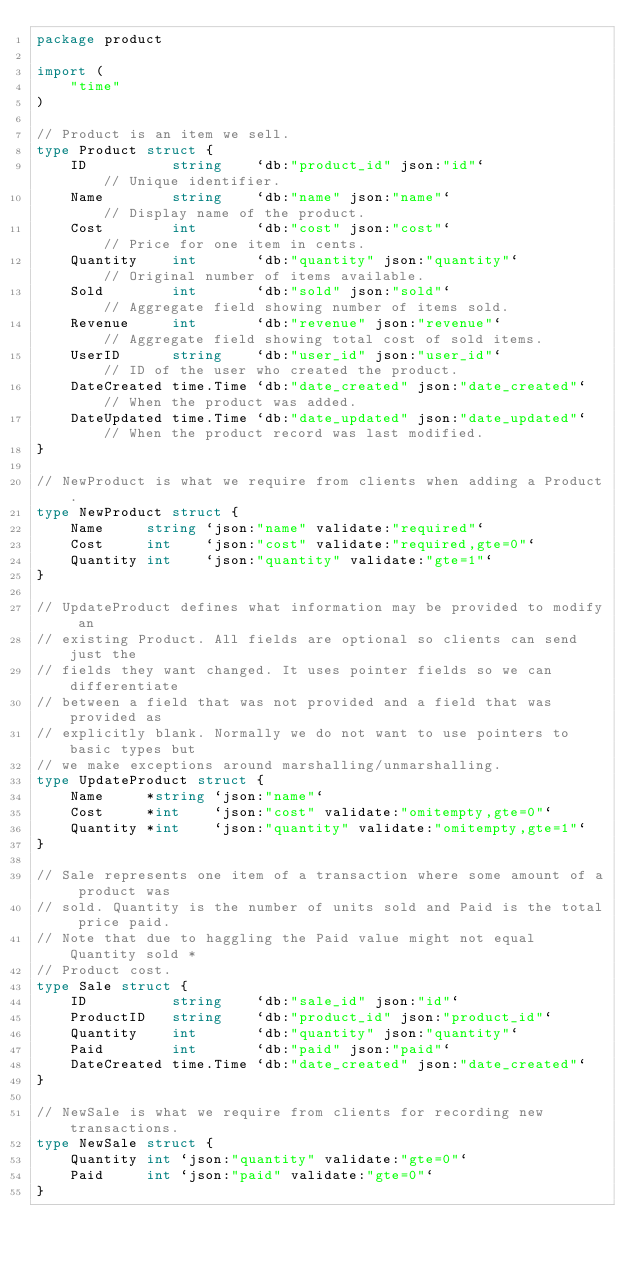<code> <loc_0><loc_0><loc_500><loc_500><_Go_>package product

import (
	"time"
)

// Product is an item we sell.
type Product struct {
	ID          string    `db:"product_id" json:"id"`             // Unique identifier.
	Name        string    `db:"name" json:"name"`                 // Display name of the product.
	Cost        int       `db:"cost" json:"cost"`                 // Price for one item in cents.
	Quantity    int       `db:"quantity" json:"quantity"`         // Original number of items available.
	Sold        int       `db:"sold" json:"sold"`                 // Aggregate field showing number of items sold.
	Revenue     int       `db:"revenue" json:"revenue"`           // Aggregate field showing total cost of sold items.
	UserID      string    `db:"user_id" json:"user_id"`           // ID of the user who created the product.
	DateCreated time.Time `db:"date_created" json:"date_created"` // When the product was added.
	DateUpdated time.Time `db:"date_updated" json:"date_updated"` // When the product record was last modified.
}

// NewProduct is what we require from clients when adding a Product.
type NewProduct struct {
	Name     string `json:"name" validate:"required"`
	Cost     int    `json:"cost" validate:"required,gte=0"`
	Quantity int    `json:"quantity" validate:"gte=1"`
}

// UpdateProduct defines what information may be provided to modify an
// existing Product. All fields are optional so clients can send just the
// fields they want changed. It uses pointer fields so we can differentiate
// between a field that was not provided and a field that was provided as
// explicitly blank. Normally we do not want to use pointers to basic types but
// we make exceptions around marshalling/unmarshalling.
type UpdateProduct struct {
	Name     *string `json:"name"`
	Cost     *int    `json:"cost" validate:"omitempty,gte=0"`
	Quantity *int    `json:"quantity" validate:"omitempty,gte=1"`
}

// Sale represents one item of a transaction where some amount of a product was
// sold. Quantity is the number of units sold and Paid is the total price paid.
// Note that due to haggling the Paid value might not equal Quantity sold *
// Product cost.
type Sale struct {
	ID          string    `db:"sale_id" json:"id"`
	ProductID   string    `db:"product_id" json:"product_id"`
	Quantity    int       `db:"quantity" json:"quantity"`
	Paid        int       `db:"paid" json:"paid"`
	DateCreated time.Time `db:"date_created" json:"date_created"`
}

// NewSale is what we require from clients for recording new transactions.
type NewSale struct {
	Quantity int `json:"quantity" validate:"gte=0"`
	Paid     int `json:"paid" validate:"gte=0"`
}
</code> 